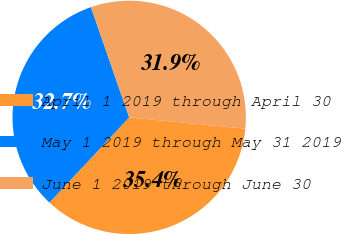<chart> <loc_0><loc_0><loc_500><loc_500><pie_chart><fcel>April 1 2019 through April 30<fcel>May 1 2019 through May 31 2019<fcel>June 1 2019 through June 30<nl><fcel>35.43%<fcel>32.71%<fcel>31.86%<nl></chart> 